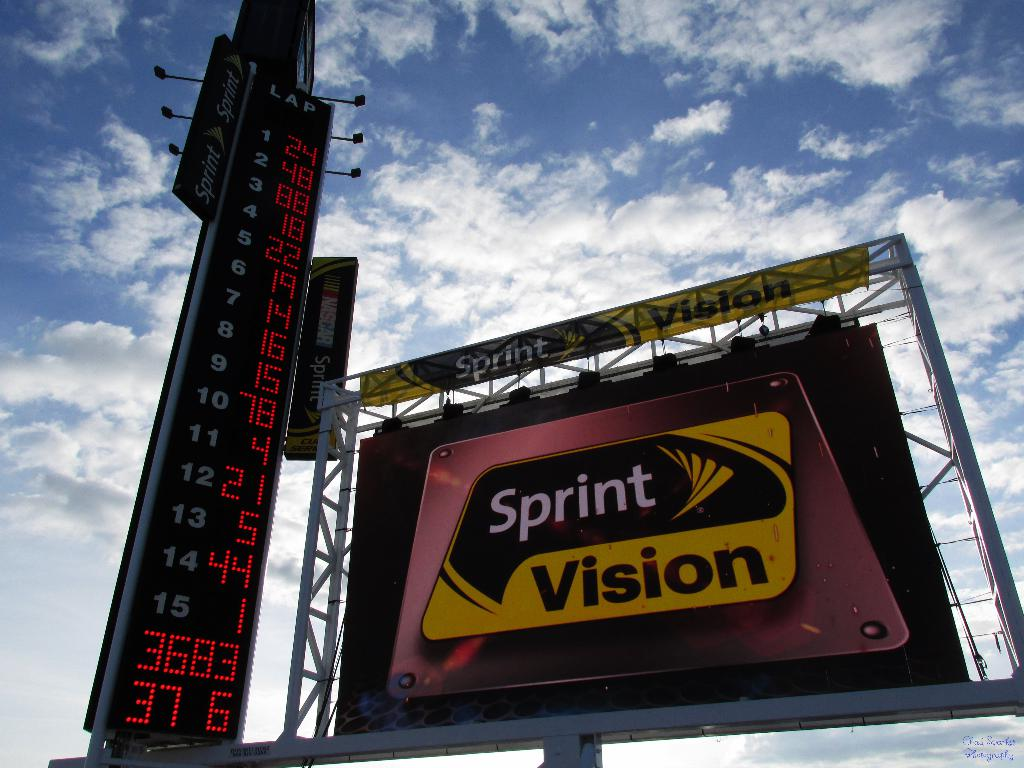What do you think is going on in this snapshot? This snapshot captures a thrilling moment at an outdoor sports event, possibly a racing competition, given the numerical data displayed on the towering scoreboard. The scoreboard shows various numbers that could represent lap times or positions, indicating the progress of the competition. The presence of 'Sprint Vision' on the billboard suggests this is a high-speed event, possibly sponsored or technologically supported by Sprint Vision, which may provide advanced visual technologies to enhance the spectator experience. The sky in the background suggests favorable weather conditions, adding to the excitement of a day at the races. 